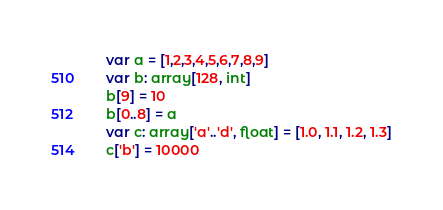<code> <loc_0><loc_0><loc_500><loc_500><_Nim_>var a = [1,2,3,4,5,6,7,8,9]
var b: array[128, int]
b[9] = 10
b[0..8] = a
var c: array['a'..'d', float] = [1.0, 1.1, 1.2, 1.3]
c['b'] = 10000
</code> 